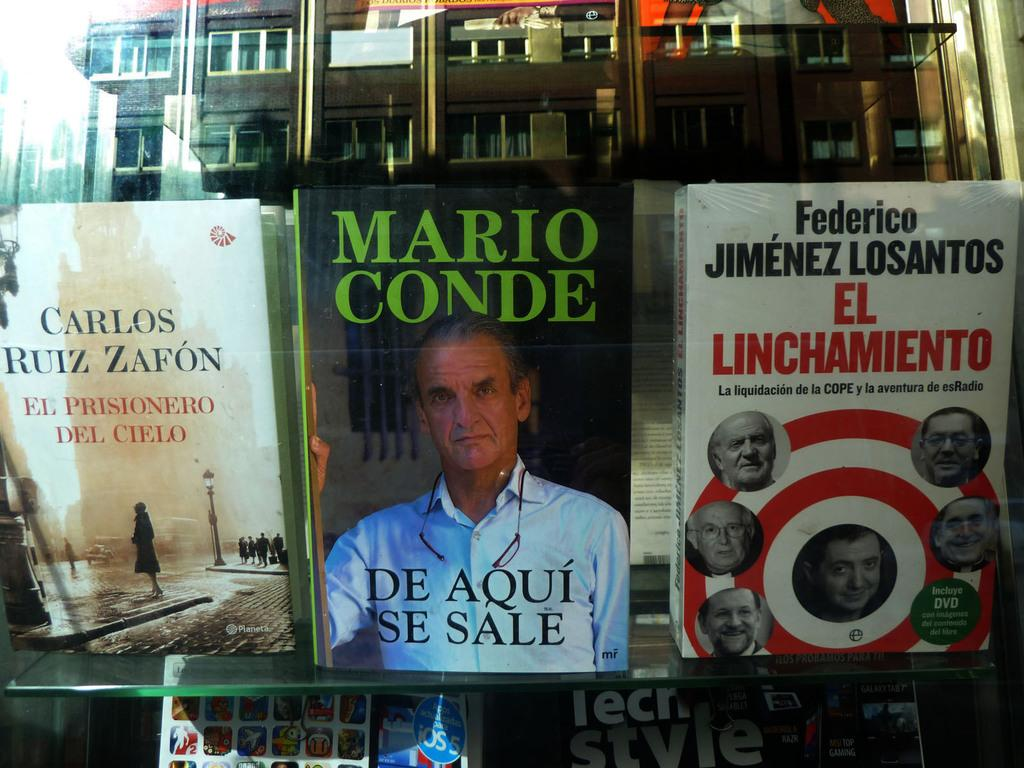Provide a one-sentence caption for the provided image. Several books on top of a bookshelf, with a book titled "De Aqui Se Sale" as the most prominent. 